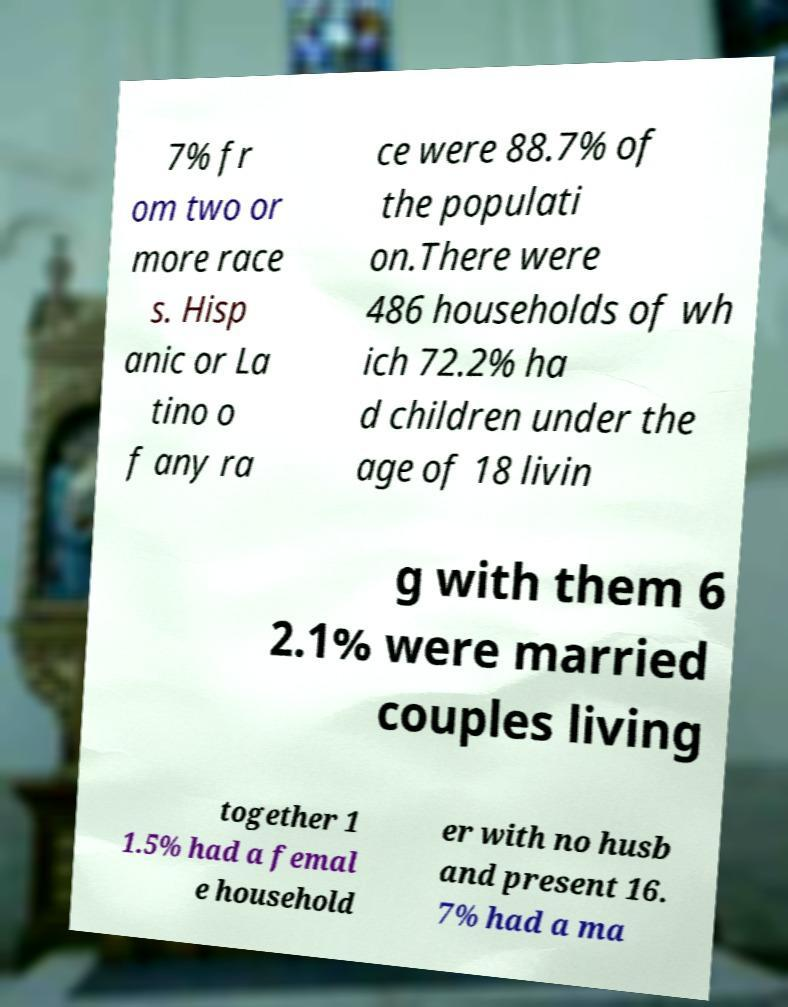There's text embedded in this image that I need extracted. Can you transcribe it verbatim? 7% fr om two or more race s. Hisp anic or La tino o f any ra ce were 88.7% of the populati on.There were 486 households of wh ich 72.2% ha d children under the age of 18 livin g with them 6 2.1% were married couples living together 1 1.5% had a femal e household er with no husb and present 16. 7% had a ma 